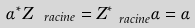<formula> <loc_0><loc_0><loc_500><loc_500>\alpha ^ { * } Z _ { \ r a c i n e } = Z _ { \ r a c i n e } ^ { * } \alpha = \alpha</formula> 